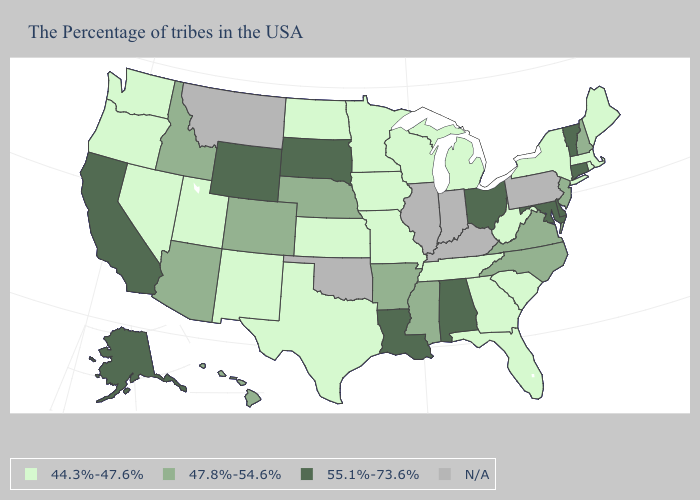What is the lowest value in states that border New Jersey?
Quick response, please. 44.3%-47.6%. What is the value of Mississippi?
Short answer required. 47.8%-54.6%. Does Arkansas have the highest value in the South?
Concise answer only. No. Name the states that have a value in the range N/A?
Quick response, please. Pennsylvania, Kentucky, Indiana, Illinois, Oklahoma, Montana. Name the states that have a value in the range 47.8%-54.6%?
Quick response, please. New Hampshire, New Jersey, Virginia, North Carolina, Mississippi, Arkansas, Nebraska, Colorado, Arizona, Idaho, Hawaii. Name the states that have a value in the range 47.8%-54.6%?
Short answer required. New Hampshire, New Jersey, Virginia, North Carolina, Mississippi, Arkansas, Nebraska, Colorado, Arizona, Idaho, Hawaii. Which states have the lowest value in the USA?
Write a very short answer. Maine, Massachusetts, Rhode Island, New York, South Carolina, West Virginia, Florida, Georgia, Michigan, Tennessee, Wisconsin, Missouri, Minnesota, Iowa, Kansas, Texas, North Dakota, New Mexico, Utah, Nevada, Washington, Oregon. What is the lowest value in states that border North Dakota?
Write a very short answer. 44.3%-47.6%. Is the legend a continuous bar?
Give a very brief answer. No. Does the map have missing data?
Keep it brief. Yes. Is the legend a continuous bar?
Quick response, please. No. 